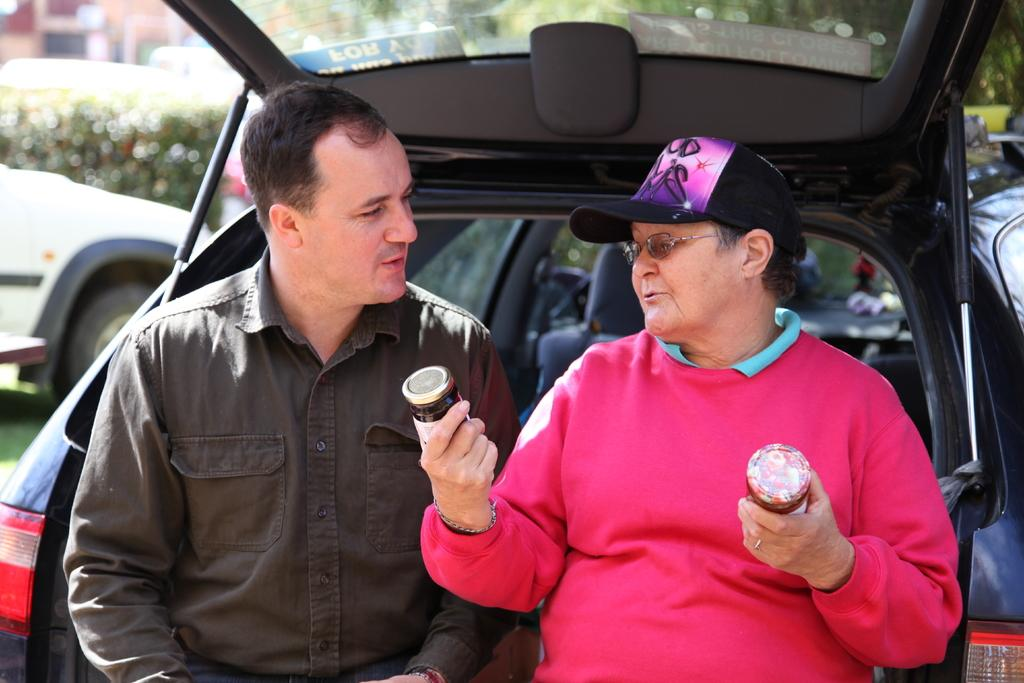How many men are present in the image? There are two men in the image. What is one of the men holding? One of the men is holding bottles. Can you describe the appearance of the man holding bottles? The man holding bottles is wearing glasses (specs) and a cap. What can be seen in the background of the image? There are vehicles and trees in the background of the image. What type of cake is being served at the curve in the image? There is no cake or curve present in the image. 